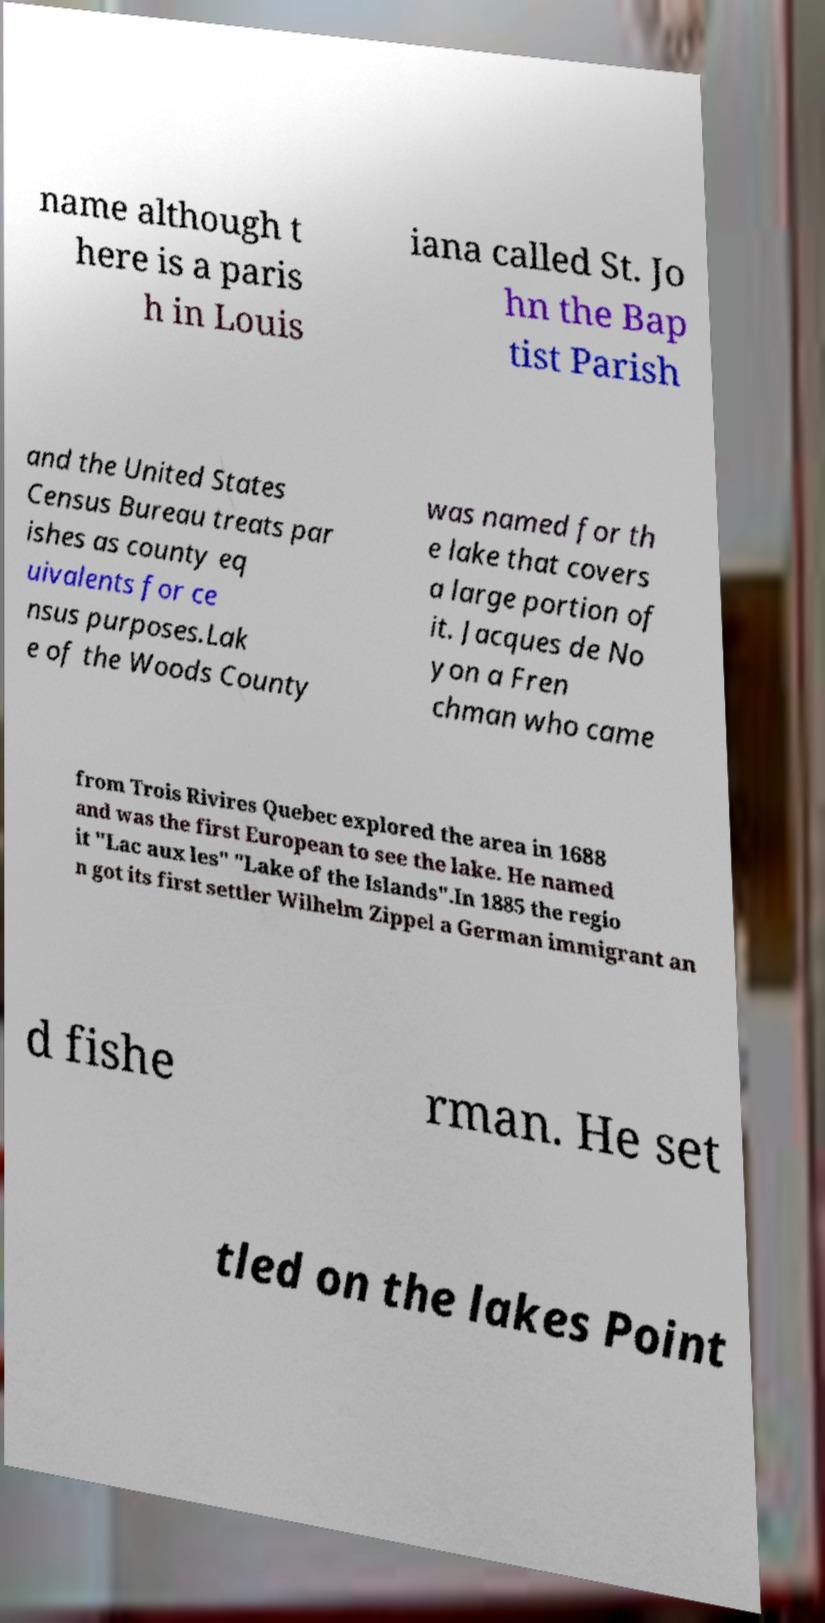Could you assist in decoding the text presented in this image and type it out clearly? name although t here is a paris h in Louis iana called St. Jo hn the Bap tist Parish and the United States Census Bureau treats par ishes as county eq uivalents for ce nsus purposes.Lak e of the Woods County was named for th e lake that covers a large portion of it. Jacques de No yon a Fren chman who came from Trois Rivires Quebec explored the area in 1688 and was the first European to see the lake. He named it "Lac aux les" "Lake of the Islands".In 1885 the regio n got its first settler Wilhelm Zippel a German immigrant an d fishe rman. He set tled on the lakes Point 